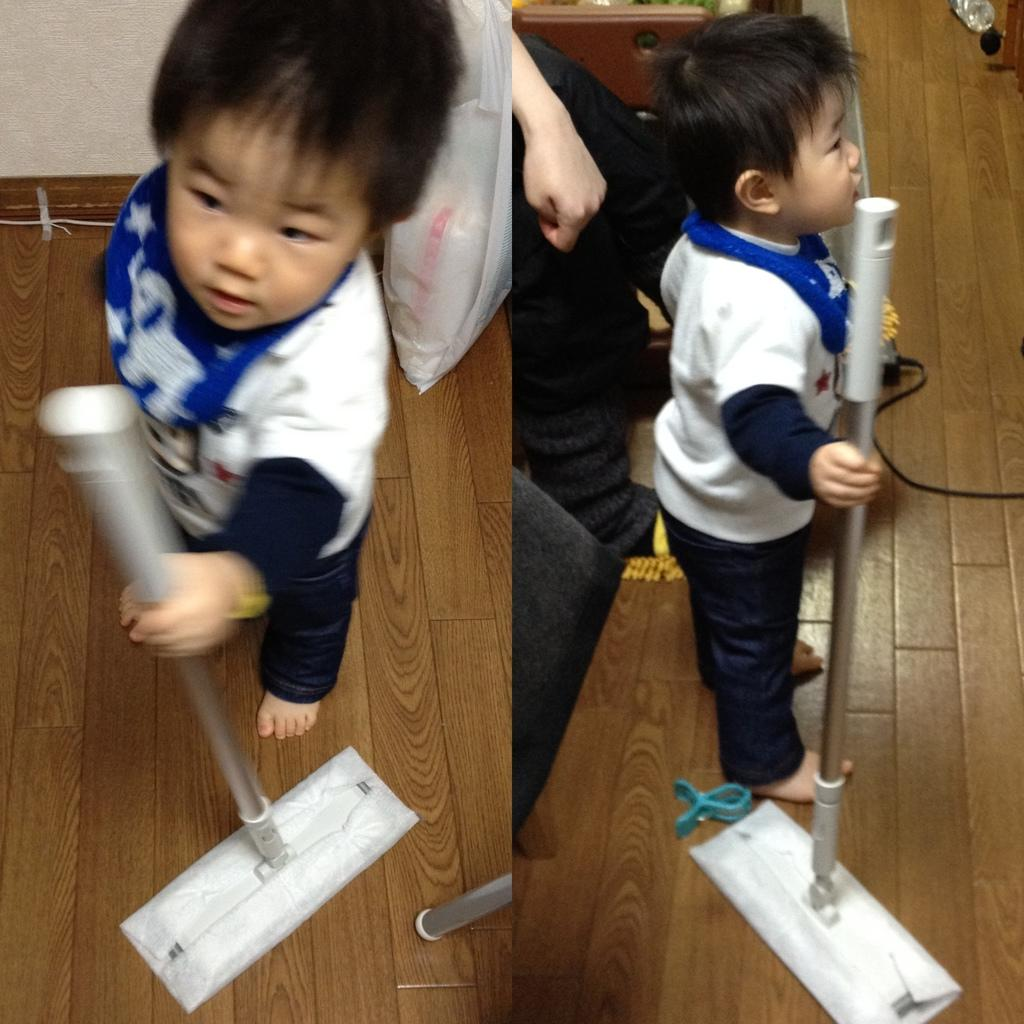What is the main subject of the image? There is a kid standing in the image. What is the kid holding in the image? The kid is holding a stick. Can you describe another person in the image? Yes, there is a person in the image. What else can be seen in the image besides the people? There are objects present in the image. What type of goose can be seen in the image? There is no goose present in the image. What historical event is depicted in the image? The image does not depict any historical event. 